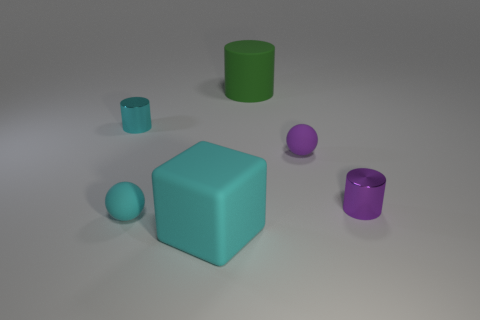Add 3 small cyan shiny objects. How many objects exist? 9 Subtract all cubes. How many objects are left? 5 Subtract 0 yellow spheres. How many objects are left? 6 Subtract all small yellow matte things. Subtract all metal objects. How many objects are left? 4 Add 6 purple matte balls. How many purple matte balls are left? 7 Add 2 tiny purple matte blocks. How many tiny purple matte blocks exist? 2 